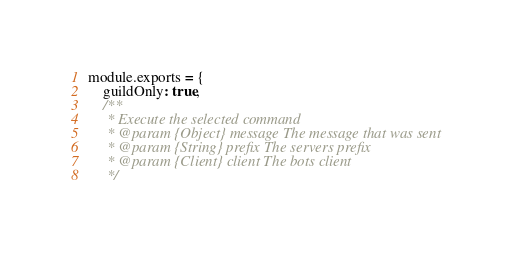Convert code to text. <code><loc_0><loc_0><loc_500><loc_500><_JavaScript_>module.exports = {
    guildOnly: true,
    /**
     * Execute the selected command
     * @param {Object} message The message that was sent
     * @param {String} prefix The servers prefix
     * @param {Client} client The bots client
     */</code> 